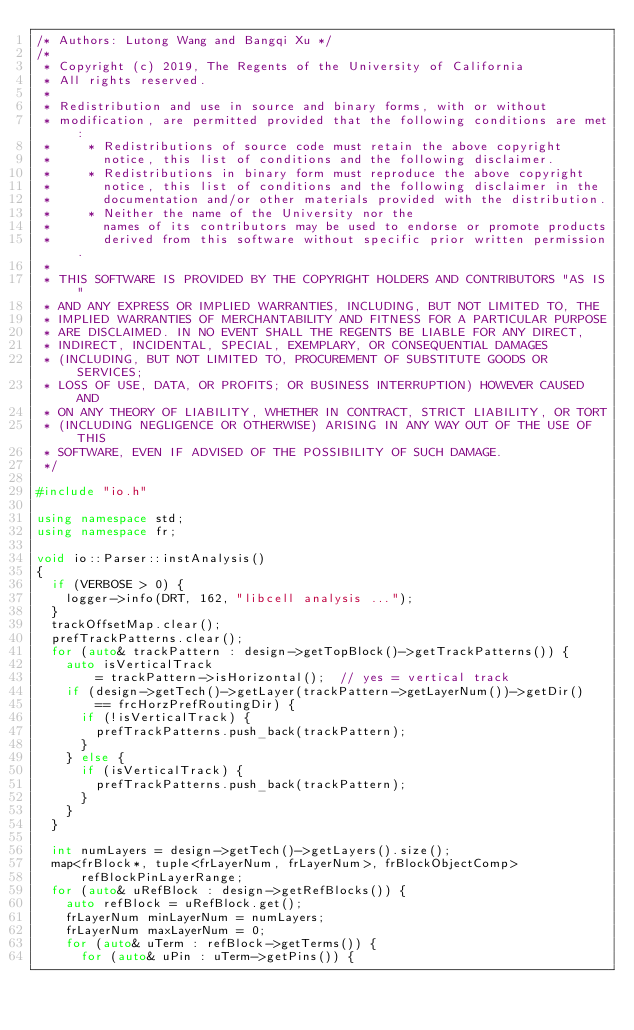Convert code to text. <code><loc_0><loc_0><loc_500><loc_500><_C++_>/* Authors: Lutong Wang and Bangqi Xu */
/*
 * Copyright (c) 2019, The Regents of the University of California
 * All rights reserved.
 *
 * Redistribution and use in source and binary forms, with or without
 * modification, are permitted provided that the following conditions are met:
 *     * Redistributions of source code must retain the above copyright
 *       notice, this list of conditions and the following disclaimer.
 *     * Redistributions in binary form must reproduce the above copyright
 *       notice, this list of conditions and the following disclaimer in the
 *       documentation and/or other materials provided with the distribution.
 *     * Neither the name of the University nor the
 *       names of its contributors may be used to endorse or promote products
 *       derived from this software without specific prior written permission.
 *
 * THIS SOFTWARE IS PROVIDED BY THE COPYRIGHT HOLDERS AND CONTRIBUTORS "AS IS"
 * AND ANY EXPRESS OR IMPLIED WARRANTIES, INCLUDING, BUT NOT LIMITED TO, THE
 * IMPLIED WARRANTIES OF MERCHANTABILITY AND FITNESS FOR A PARTICULAR PURPOSE
 * ARE DISCLAIMED. IN NO EVENT SHALL THE REGENTS BE LIABLE FOR ANY DIRECT,
 * INDIRECT, INCIDENTAL, SPECIAL, EXEMPLARY, OR CONSEQUENTIAL DAMAGES
 * (INCLUDING, BUT NOT LIMITED TO, PROCUREMENT OF SUBSTITUTE GOODS OR SERVICES;
 * LOSS OF USE, DATA, OR PROFITS; OR BUSINESS INTERRUPTION) HOWEVER CAUSED AND
 * ON ANY THEORY OF LIABILITY, WHETHER IN CONTRACT, STRICT LIABILITY, OR TORT
 * (INCLUDING NEGLIGENCE OR OTHERWISE) ARISING IN ANY WAY OUT OF THE USE OF THIS
 * SOFTWARE, EVEN IF ADVISED OF THE POSSIBILITY OF SUCH DAMAGE.
 */

#include "io.h"

using namespace std;
using namespace fr;

void io::Parser::instAnalysis()
{
  if (VERBOSE > 0) {
    logger->info(DRT, 162, "libcell analysis ...");
  }
  trackOffsetMap.clear();
  prefTrackPatterns.clear();
  for (auto& trackPattern : design->getTopBlock()->getTrackPatterns()) {
    auto isVerticalTrack
        = trackPattern->isHorizontal();  // yes = vertical track
    if (design->getTech()->getLayer(trackPattern->getLayerNum())->getDir()
        == frcHorzPrefRoutingDir) {
      if (!isVerticalTrack) {
        prefTrackPatterns.push_back(trackPattern);
      }
    } else {
      if (isVerticalTrack) {
        prefTrackPatterns.push_back(trackPattern);
      }
    }
  }

  int numLayers = design->getTech()->getLayers().size();
  map<frBlock*, tuple<frLayerNum, frLayerNum>, frBlockObjectComp>
      refBlockPinLayerRange;
  for (auto& uRefBlock : design->getRefBlocks()) {
    auto refBlock = uRefBlock.get();
    frLayerNum minLayerNum = numLayers;
    frLayerNum maxLayerNum = 0;
    for (auto& uTerm : refBlock->getTerms()) {
      for (auto& uPin : uTerm->getPins()) {</code> 